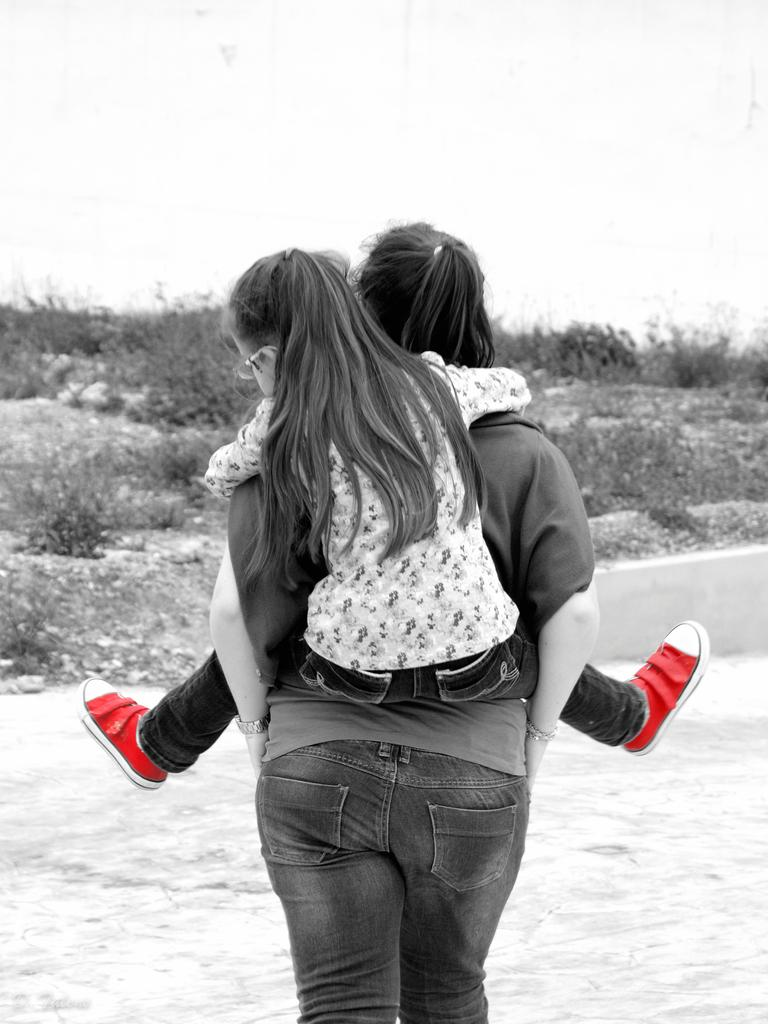Who is the main subject in the image? There is a woman in the image. What is the woman doing in the image? The woman is holding a child. What action is the woman and child engaged in? The woman and child are walking. What can be seen at the bottom of the image? There is a ground visible at the bottom of the image. What type of environment is depicted in the background of the image? There are plants in the background of the image. What type of beam is supporting the writer in the image? There is no writer or beam present in the image. What is the income of the woman in the image? The income of the woman cannot be determined from the image. 